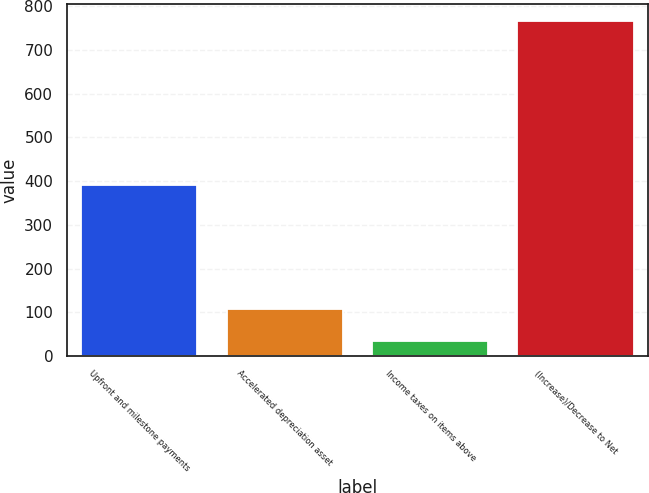<chart> <loc_0><loc_0><loc_500><loc_500><bar_chart><fcel>Upfront and milestone payments<fcel>Accelerated depreciation asset<fcel>Income taxes on items above<fcel>(Increase)/Decrease to Net<nl><fcel>392<fcel>106.4<fcel>33<fcel>767<nl></chart> 